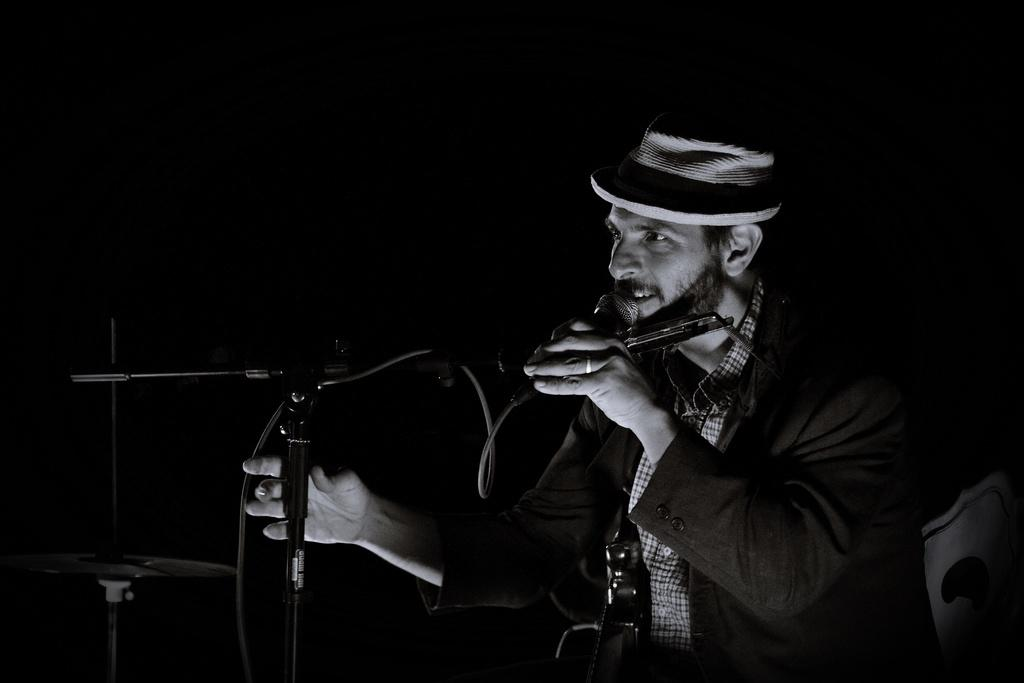Who is the main subject in the image? There is a man in the image. Where is the man located in the image? The man is sitting at the right side of the image. What is the man holding in his hand? The man is holding a mic in his hand. What is the man doing with the mic? The man is speaking into the mic. What is the color of the background in the image? The background color is black. What type of rings is the man wearing on his fingers in the image? There is no mention of rings in the image, so we cannot determine if the man is wearing any rings. 